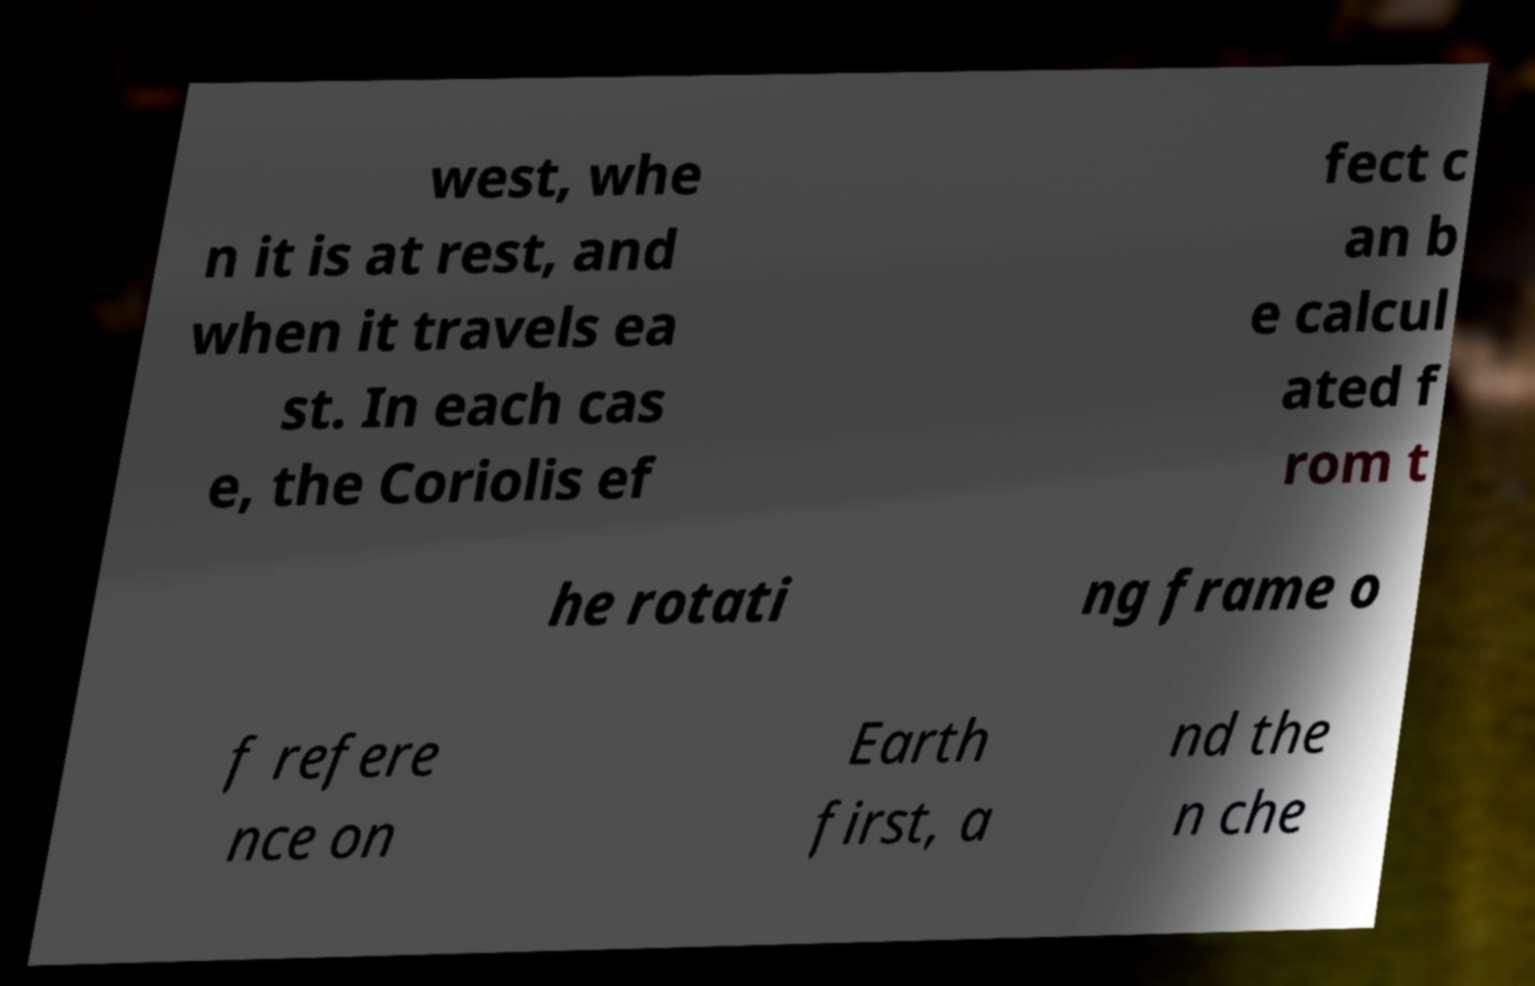What messages or text are displayed in this image? I need them in a readable, typed format. west, whe n it is at rest, and when it travels ea st. In each cas e, the Coriolis ef fect c an b e calcul ated f rom t he rotati ng frame o f refere nce on Earth first, a nd the n che 